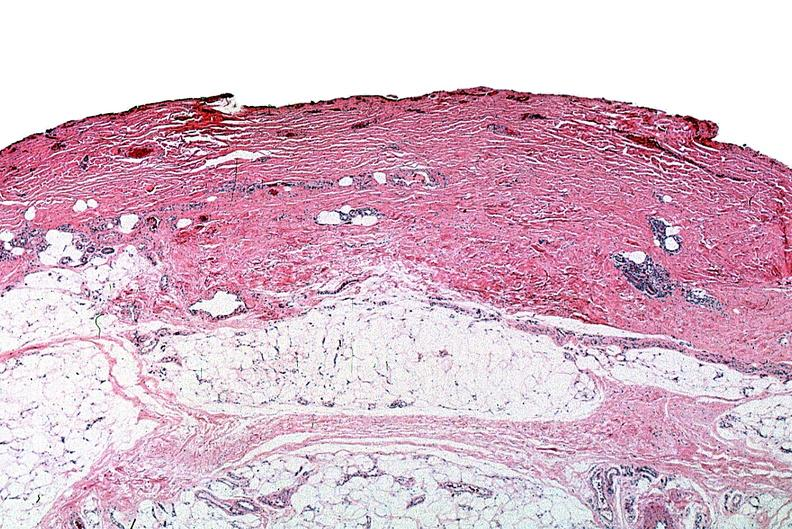does this image show thermal burned skin?
Answer the question using a single word or phrase. Yes 